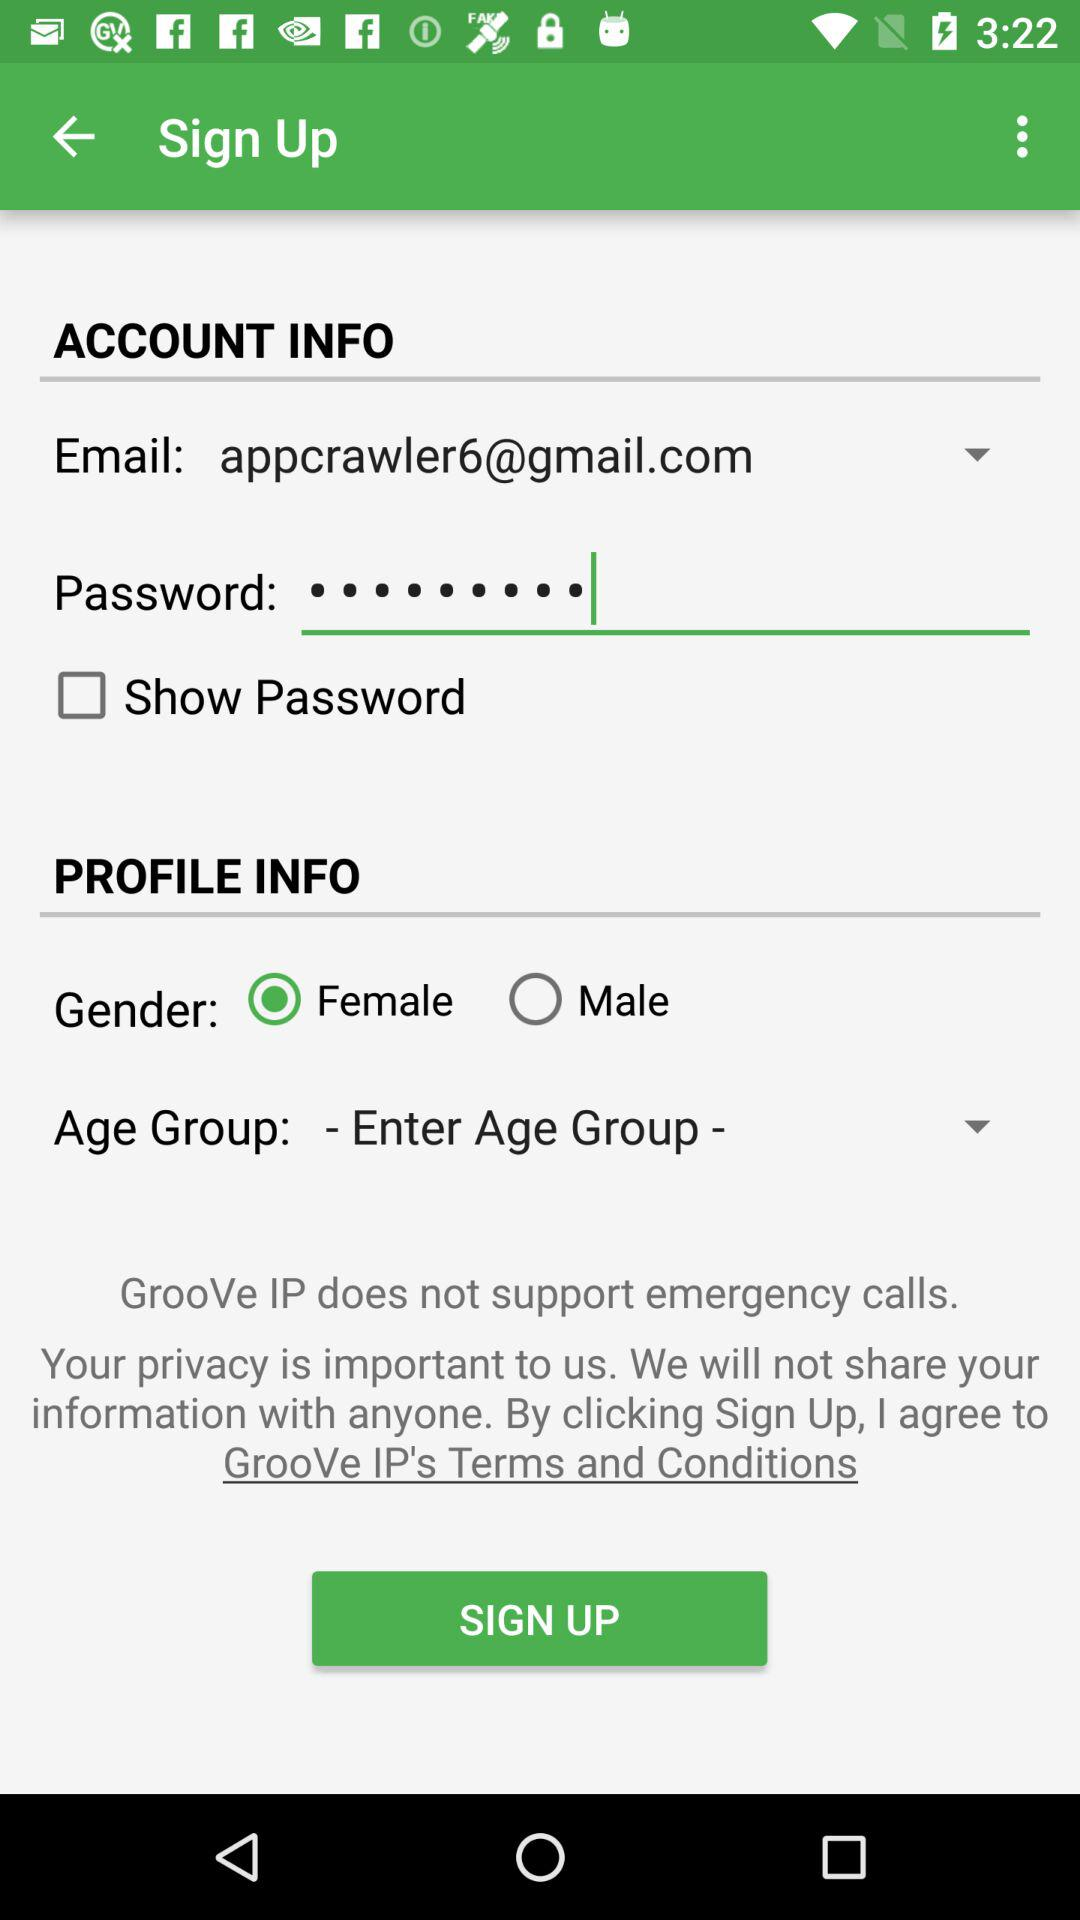What is the gender? The gender is female. 